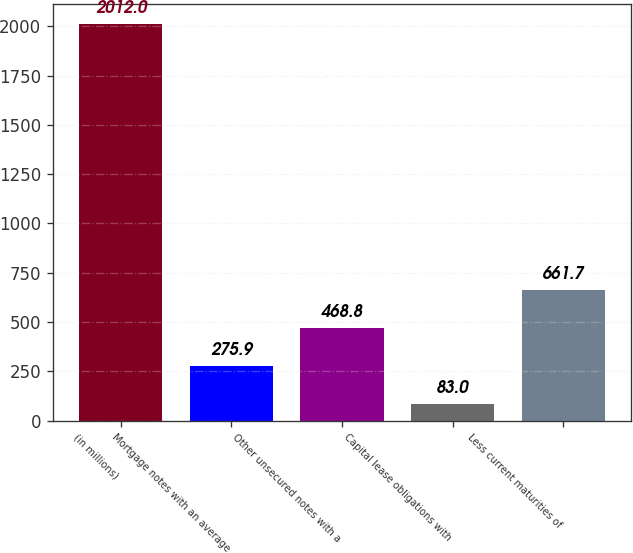<chart> <loc_0><loc_0><loc_500><loc_500><bar_chart><fcel>(in millions)<fcel>Mortgage notes with an average<fcel>Other unsecured notes with a<fcel>Capital lease obligations with<fcel>Less current maturities of<nl><fcel>2012<fcel>275.9<fcel>468.8<fcel>83<fcel>661.7<nl></chart> 